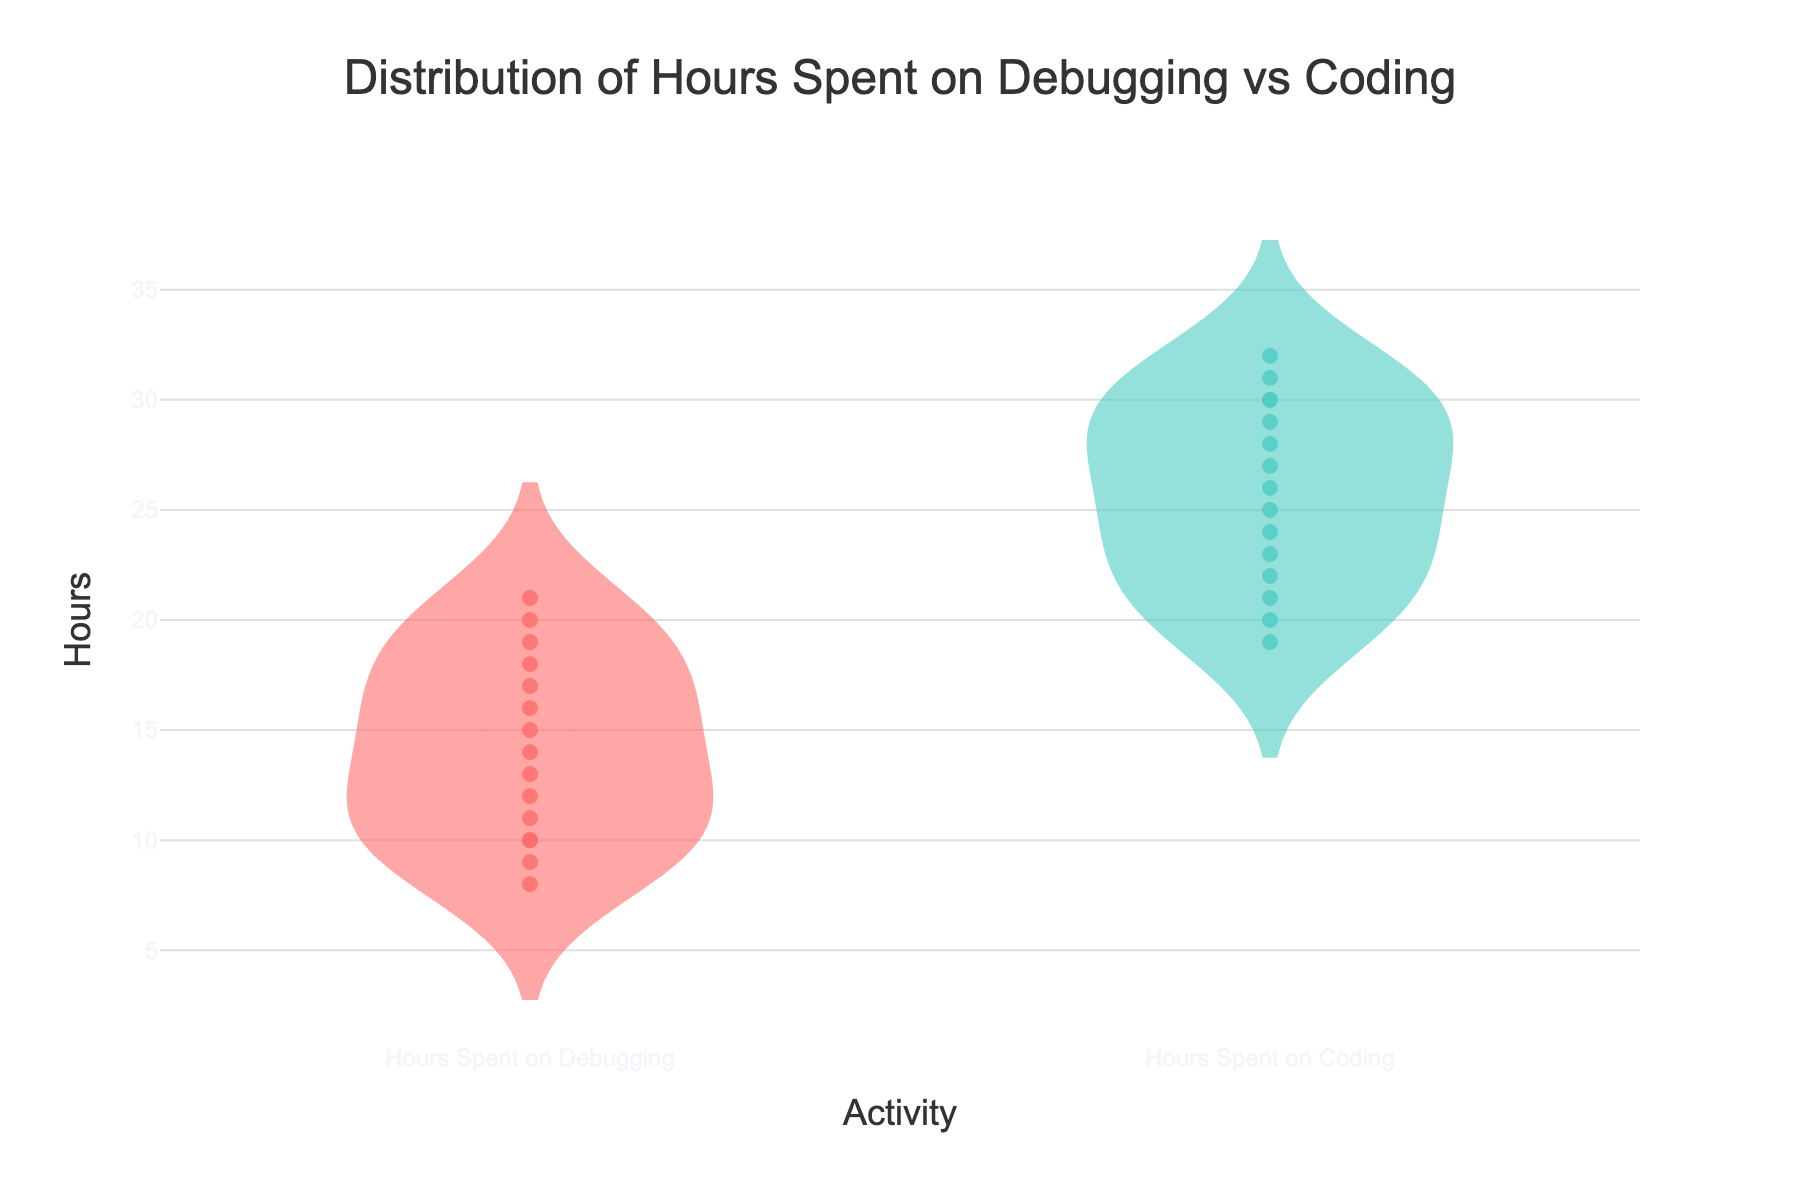What is the title of the figure? The figure shows a title at the top which reads "Distribution of Hours Spent on Debugging vs Coding". You can see this information by reading the text prominently displayed at the top of the plot.
Answer: Distribution of Hours Spent on Debugging vs Coding How many activities are displayed on the x-axis? By looking at the x-axis, we can see that there are two activities displayed: "Hours Spent on Debugging" and "Hours Spent on Coding".
Answer: Two What is the range of hours for coding? Observing the distribution on the coding side of the plot, the minimum value is 19 and the maximum value is 32. The range can be calculated as the difference between these two values.
Answer: 13 Which activity has more consistent hours among the developers, debugging, or coding? By looking at the box plots within the violins and their spread, "Hours Spent on Coding" shows a more consistent set of values with less variability compared to "Hours Spent on Debugging."
Answer: Coding What are the median hours spent on debugging and coding respectively? The horizontal line inside each box on the violin plots represents the median. For debugging, the median is around 15, and for coding, it is around 25.
Answer: Debugging: 15, Coding: 25 What is the average difference between hours spent on debugging and coding? First, we need to find the hours for each activity. Subtract the debugging hours from the coding hours for each developer, sum up the differences, and then divide by the number of developers (15). The individual differences are: 10, 20, 0, 16, 4, 22, 8, 12, 18, 6, 14, 2, 20, 24, -2, which total 174. Divide this by 15 yields the average difference.
Answer: 11.6 Which developer spent the most hours on debugging? By looking at the jittered points on the "Hours Spent on Debugging" violin, you can hover over and see that Olivia Turner spent the most hours with 21.
Answer: Olivia Turner Is there any developer who spent the same number of hours on debugging and coding? Observing the jittered points on both sides, Linda Nguyen is the developer who has the same number of hours, which is 20 hours spent on both debugging and coding.
Answer: Linda Nguyen Which developer has the highest total hours combined for debugging and coding? To find this, we look at the combination of hours for both activities and sum them. Robert Brown has 9 (debugging) + 31 (coding) = 40 hours, which is the highest total.
Answer: Robert Brown 